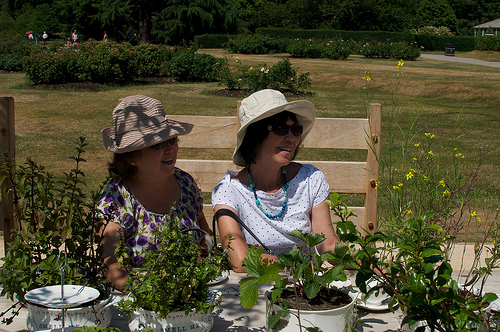<image>
Can you confirm if the woman is next to the woman? Yes. The woman is positioned adjacent to the woman, located nearby in the same general area. Is the hat in front of the chair? Yes. The hat is positioned in front of the chair, appearing closer to the camera viewpoint. 